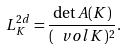<formula> <loc_0><loc_0><loc_500><loc_500>L _ { K } ^ { 2 d } = \frac { \det A ( K ) } { ( \ v o l K ) ^ { 2 } } .</formula> 